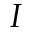<formula> <loc_0><loc_0><loc_500><loc_500>I</formula> 